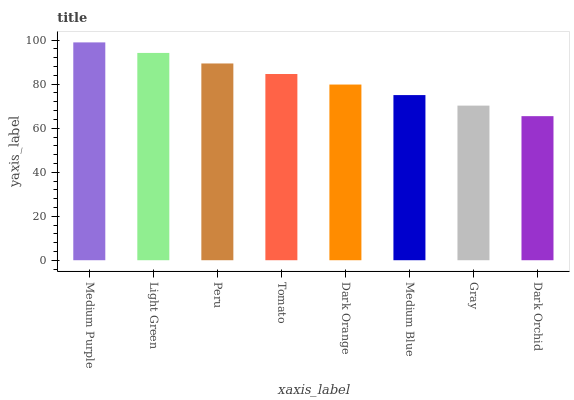Is Dark Orchid the minimum?
Answer yes or no. Yes. Is Medium Purple the maximum?
Answer yes or no. Yes. Is Light Green the minimum?
Answer yes or no. No. Is Light Green the maximum?
Answer yes or no. No. Is Medium Purple greater than Light Green?
Answer yes or no. Yes. Is Light Green less than Medium Purple?
Answer yes or no. Yes. Is Light Green greater than Medium Purple?
Answer yes or no. No. Is Medium Purple less than Light Green?
Answer yes or no. No. Is Tomato the high median?
Answer yes or no. Yes. Is Dark Orange the low median?
Answer yes or no. Yes. Is Peru the high median?
Answer yes or no. No. Is Medium Blue the low median?
Answer yes or no. No. 